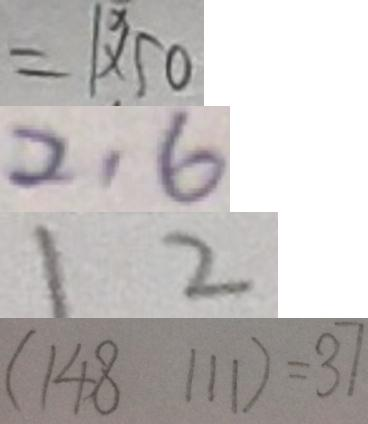<formula> <loc_0><loc_0><loc_500><loc_500>= 1 \times 5 0 
 2 1 6 
 1 2 
 ( 1 4 8 1 1 1 ) = 3 7</formula> 